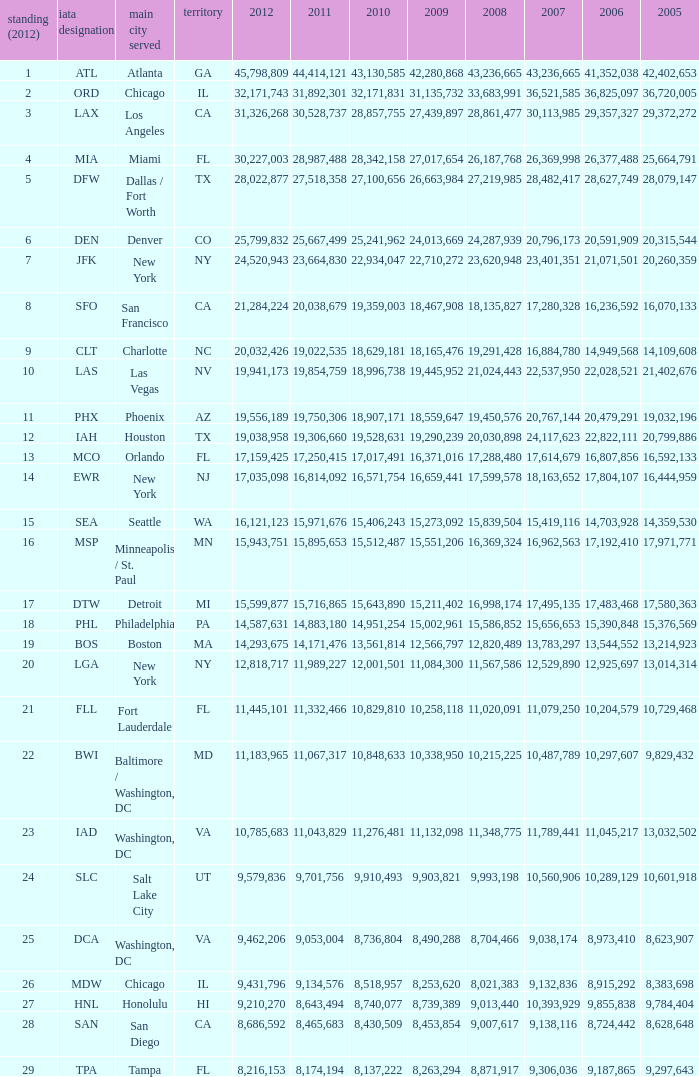What is the greatest 2010 for Miami, Fl? 28342158.0. 